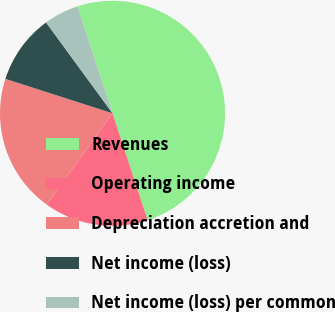Convert chart. <chart><loc_0><loc_0><loc_500><loc_500><pie_chart><fcel>Revenues<fcel>Operating income<fcel>Depreciation accretion and<fcel>Net income (loss)<fcel>Net income (loss) per common<nl><fcel>50.0%<fcel>15.0%<fcel>20.0%<fcel>10.0%<fcel>5.0%<nl></chart> 